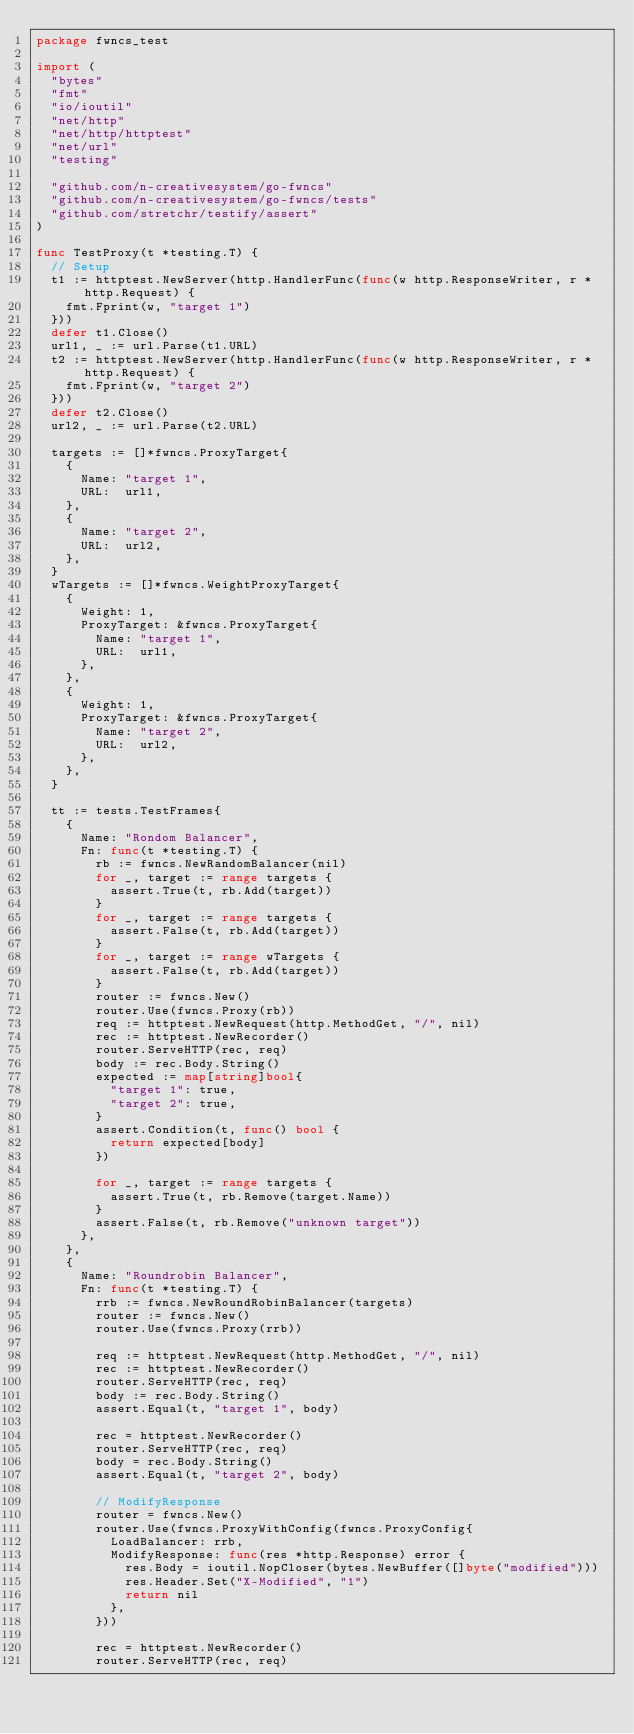<code> <loc_0><loc_0><loc_500><loc_500><_Go_>package fwncs_test

import (
	"bytes"
	"fmt"
	"io/ioutil"
	"net/http"
	"net/http/httptest"
	"net/url"
	"testing"

	"github.com/n-creativesystem/go-fwncs"
	"github.com/n-creativesystem/go-fwncs/tests"
	"github.com/stretchr/testify/assert"
)

func TestProxy(t *testing.T) {
	// Setup
	t1 := httptest.NewServer(http.HandlerFunc(func(w http.ResponseWriter, r *http.Request) {
		fmt.Fprint(w, "target 1")
	}))
	defer t1.Close()
	url1, _ := url.Parse(t1.URL)
	t2 := httptest.NewServer(http.HandlerFunc(func(w http.ResponseWriter, r *http.Request) {
		fmt.Fprint(w, "target 2")
	}))
	defer t2.Close()
	url2, _ := url.Parse(t2.URL)

	targets := []*fwncs.ProxyTarget{
		{
			Name: "target 1",
			URL:  url1,
		},
		{
			Name: "target 2",
			URL:  url2,
		},
	}
	wTargets := []*fwncs.WeightProxyTarget{
		{
			Weight: 1,
			ProxyTarget: &fwncs.ProxyTarget{
				Name: "target 1",
				URL:  url1,
			},
		},
		{
			Weight: 1,
			ProxyTarget: &fwncs.ProxyTarget{
				Name: "target 2",
				URL:  url2,
			},
		},
	}

	tt := tests.TestFrames{
		{
			Name: "Rondom Balancer",
			Fn: func(t *testing.T) {
				rb := fwncs.NewRandomBalancer(nil)
				for _, target := range targets {
					assert.True(t, rb.Add(target))
				}
				for _, target := range targets {
					assert.False(t, rb.Add(target))
				}
				for _, target := range wTargets {
					assert.False(t, rb.Add(target))
				}
				router := fwncs.New()
				router.Use(fwncs.Proxy(rb))
				req := httptest.NewRequest(http.MethodGet, "/", nil)
				rec := httptest.NewRecorder()
				router.ServeHTTP(rec, req)
				body := rec.Body.String()
				expected := map[string]bool{
					"target 1": true,
					"target 2": true,
				}
				assert.Condition(t, func() bool {
					return expected[body]
				})

				for _, target := range targets {
					assert.True(t, rb.Remove(target.Name))
				}
				assert.False(t, rb.Remove("unknown target"))
			},
		},
		{
			Name: "Roundrobin Balancer",
			Fn: func(t *testing.T) {
				rrb := fwncs.NewRoundRobinBalancer(targets)
				router := fwncs.New()
				router.Use(fwncs.Proxy(rrb))

				req := httptest.NewRequest(http.MethodGet, "/", nil)
				rec := httptest.NewRecorder()
				router.ServeHTTP(rec, req)
				body := rec.Body.String()
				assert.Equal(t, "target 1", body)

				rec = httptest.NewRecorder()
				router.ServeHTTP(rec, req)
				body = rec.Body.String()
				assert.Equal(t, "target 2", body)

				// ModifyResponse
				router = fwncs.New()
				router.Use(fwncs.ProxyWithConfig(fwncs.ProxyConfig{
					LoadBalancer: rrb,
					ModifyResponse: func(res *http.Response) error {
						res.Body = ioutil.NopCloser(bytes.NewBuffer([]byte("modified")))
						res.Header.Set("X-Modified", "1")
						return nil
					},
				}))

				rec = httptest.NewRecorder()
				router.ServeHTTP(rec, req)</code> 